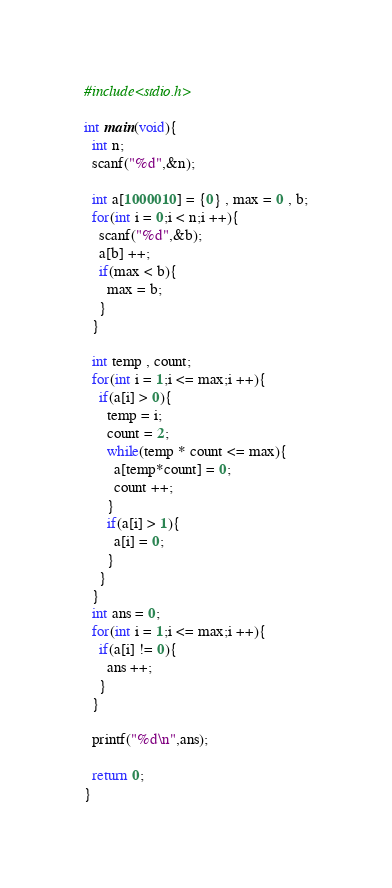<code> <loc_0><loc_0><loc_500><loc_500><_C_>#include<stdio.h>

int main(void){
  int n;
  scanf("%d",&n);

  int a[1000010] = {0} , max = 0 , b;
  for(int i = 0;i < n;i ++){
    scanf("%d",&b);
    a[b] ++;
    if(max < b){
      max = b;
    }
  }

  int temp , count;
  for(int i = 1;i <= max;i ++){
    if(a[i] > 0){
      temp = i;
      count = 2;
      while(temp * count <= max){
        a[temp*count] = 0;
        count ++;
      }
      if(a[i] > 1){
        a[i] = 0;
      }
    }
  }
  int ans = 0;
  for(int i = 1;i <= max;i ++){
    if(a[i] != 0){
      ans ++;
    }
  }

  printf("%d\n",ans);

  return 0;
}</code> 